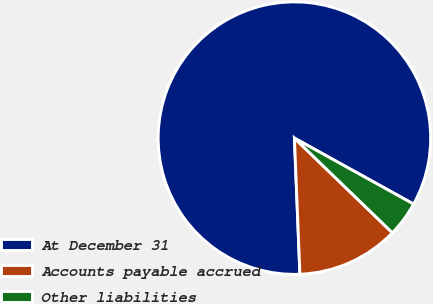<chart> <loc_0><loc_0><loc_500><loc_500><pie_chart><fcel>At December 31<fcel>Accounts payable accrued<fcel>Other liabilities<nl><fcel>83.69%<fcel>12.13%<fcel>4.18%<nl></chart> 